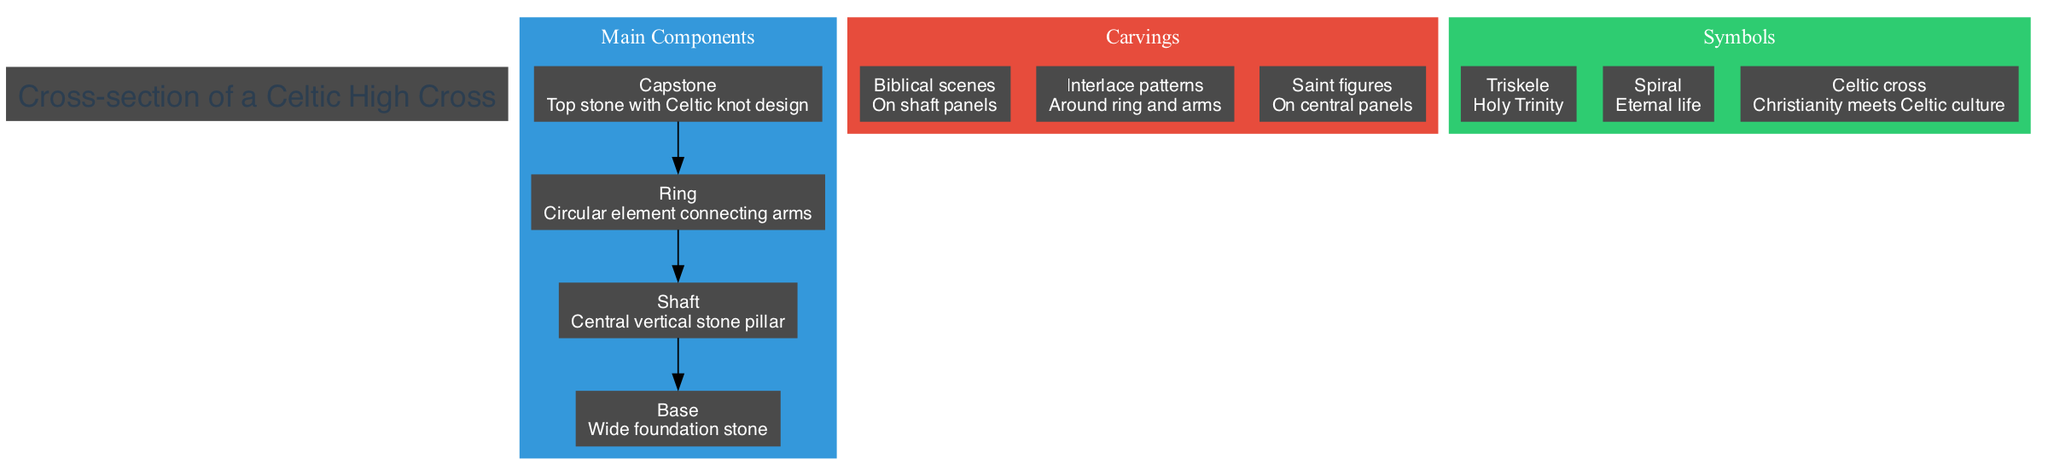What is the top stone of the Celtic high cross called? The diagram identifies the top stone as the "Capstone." This information can be found directly in the "Main Components" section, clearly labeling it as such.
Answer: Capstone What decorative element is around the ring and arms? The diagram specifies that "Interlace patterns" are located around the ring and arms, providing a clear description of the carvings found there.
Answer: Interlace patterns How many main components are there in the diagram? To determine the number of main components, one can count the listed elements in the "Main Components" section, which includes Capstone, Ring, Shaft, and Base, totaling four.
Answer: 4 What does the symbol "Triskele" represent? The diagram explains that "Triskele" is a symbol indicative of the "Holy Trinity," providing the meaning directly associated with this symbol in the "Symbols" section.
Answer: Holy Trinity Which part of the high cross features biblical scenes? According to the "Carvings" section, it is stated that biblical scenes are found "On shaft panels," identifying the specific part of the high cross where these carvings can be seen.
Answer: On shaft panels What connects the arms of the high cross? The diagram illustrates that the "Ring" is the circular element that connects the arms of the high cross, explicitly labeling it in the "Main Components" section.
Answer: Ring What is the meaning of the spiral symbol? The diagram specifies that the "Spiral" symbol represents "Eternal life," directly linking the symbol to its meaning within the "Symbols" section.
Answer: Eternal life Where are the saint figures located on the high cross? The diagram indicates that the "Saint figures" are located "On central panels," pinpointing their exact position on the high cross as described in the "Carvings" section.
Answer: On central panels What is the foundation stone of the high cross called? The diagram refers to the foundation stone as the "Base," clearly labeling it in the "Main Components" section.
Answer: Base 